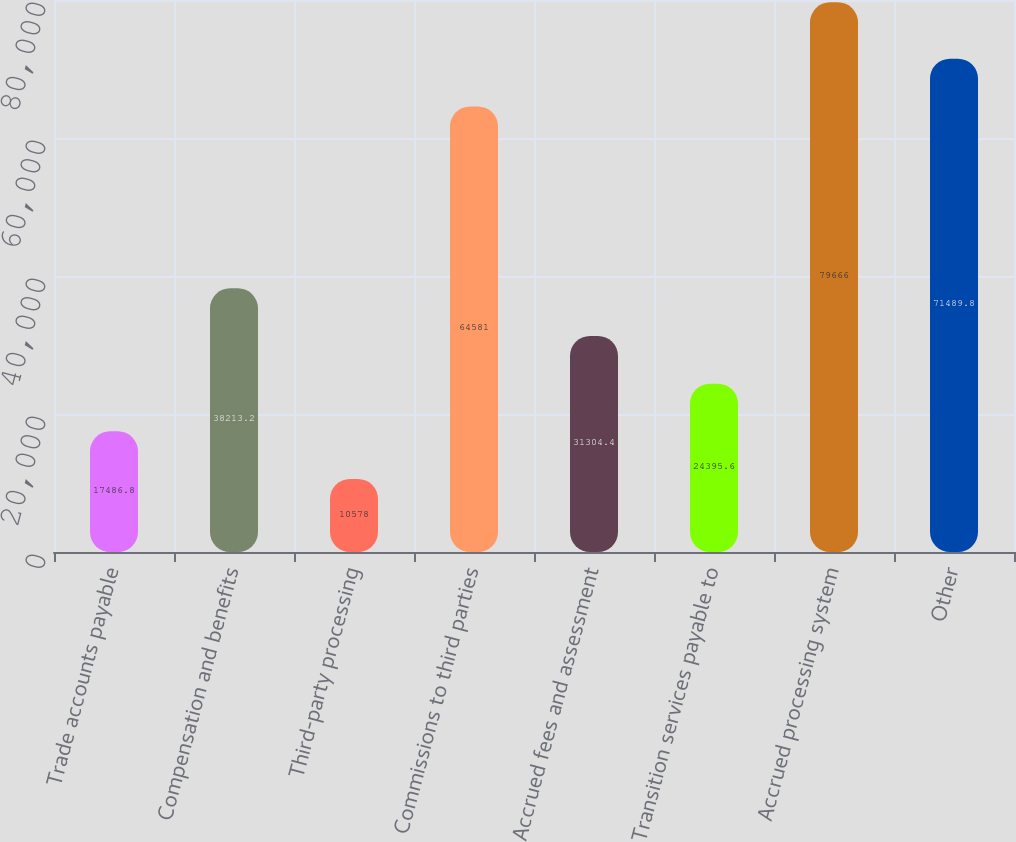Convert chart. <chart><loc_0><loc_0><loc_500><loc_500><bar_chart><fcel>Trade accounts payable<fcel>Compensation and benefits<fcel>Third-party processing<fcel>Commissions to third parties<fcel>Accrued fees and assessment<fcel>Transition services payable to<fcel>Accrued processing system<fcel>Other<nl><fcel>17486.8<fcel>38213.2<fcel>10578<fcel>64581<fcel>31304.4<fcel>24395.6<fcel>79666<fcel>71489.8<nl></chart> 